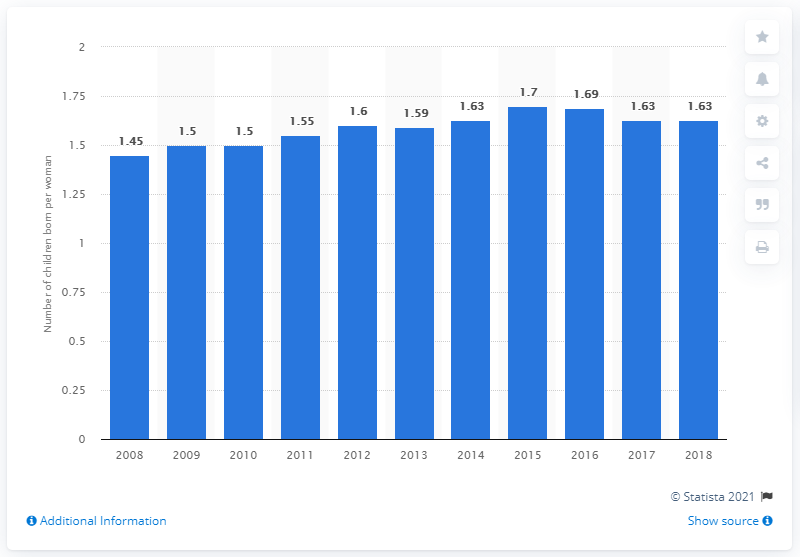Give some essential details in this illustration. The fertility rate in Lithuania in 2018 was 1.63. 